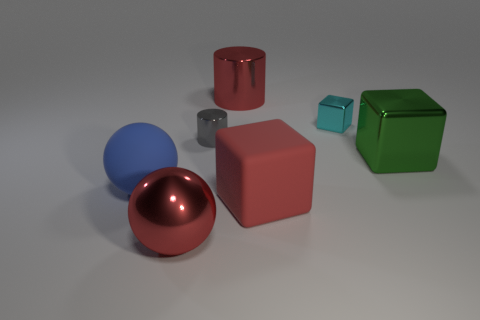Are there fewer big matte objects than large yellow spheres?
Give a very brief answer. No. What material is the red cylinder that is the same size as the green shiny cube?
Keep it short and to the point. Metal. Are there more small cyan metallic objects than red matte spheres?
Provide a succinct answer. Yes. How many other objects are there of the same color as the matte cube?
Offer a very short reply. 2. What number of things are both in front of the big blue sphere and behind the large metallic sphere?
Offer a terse response. 1. Is there any other thing that is the same size as the cyan cube?
Make the answer very short. Yes. Are there more large metallic things that are in front of the gray metallic object than green cubes that are on the left side of the small cyan metal thing?
Offer a very short reply. Yes. There is a big red thing that is on the left side of the large cylinder; what is it made of?
Your answer should be compact. Metal. Does the green object have the same shape as the red thing that is behind the green thing?
Offer a terse response. No. There is a red metal thing that is behind the object to the left of the big red sphere; what number of red cylinders are behind it?
Give a very brief answer. 0. 